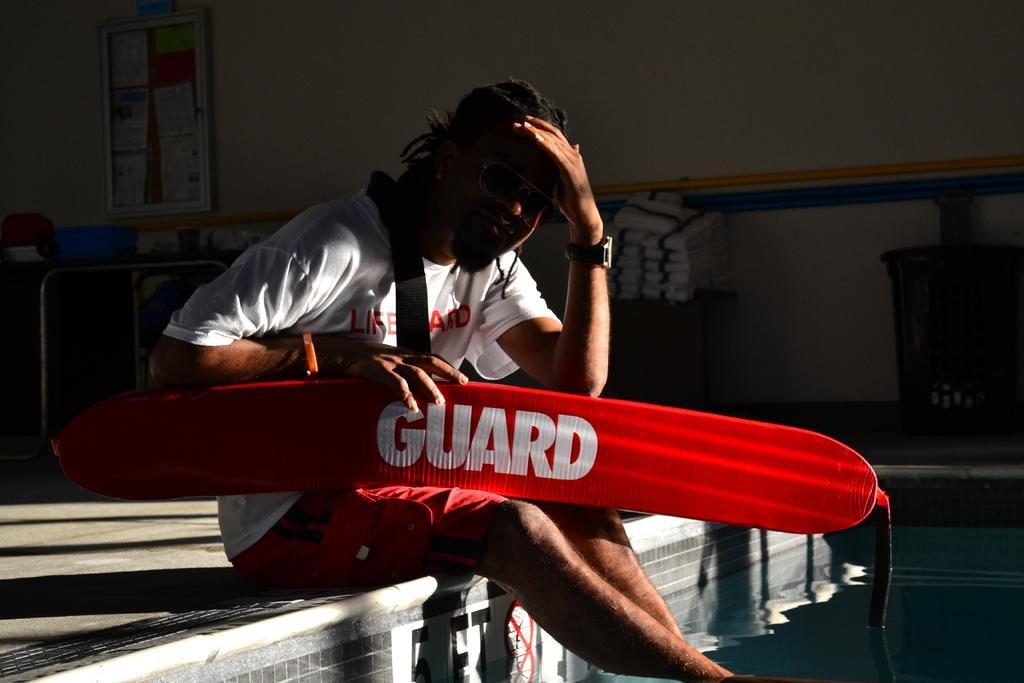How would you summarize this image in a sentence or two? In this image we can see a person sitting on a floor and holding a red color object, on the right side of the image there is water and in the background there is a table and clothes on the table and there is a board attached to the wall. 